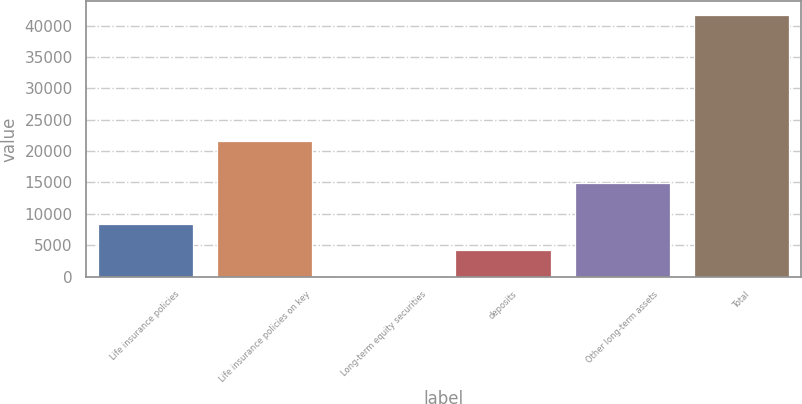<chart> <loc_0><loc_0><loc_500><loc_500><bar_chart><fcel>Life insurance policies<fcel>Life insurance policies on key<fcel>Long-term equity securities<fcel>deposits<fcel>Other long-term assets<fcel>Total<nl><fcel>8428.6<fcel>21602<fcel>100<fcel>4264.3<fcel>14978<fcel>41743<nl></chart> 